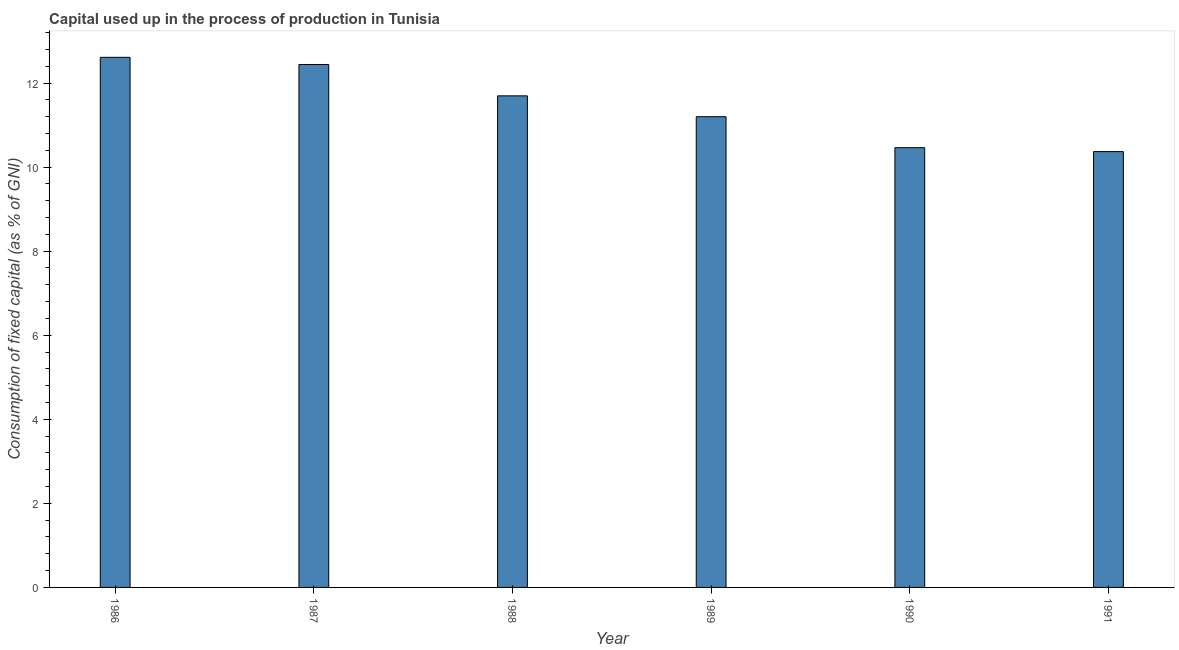Does the graph contain any zero values?
Your response must be concise. No. What is the title of the graph?
Ensure brevity in your answer.  Capital used up in the process of production in Tunisia. What is the label or title of the Y-axis?
Give a very brief answer. Consumption of fixed capital (as % of GNI). What is the consumption of fixed capital in 1991?
Ensure brevity in your answer.  10.37. Across all years, what is the maximum consumption of fixed capital?
Provide a short and direct response. 12.61. Across all years, what is the minimum consumption of fixed capital?
Your answer should be very brief. 10.37. In which year was the consumption of fixed capital minimum?
Make the answer very short. 1991. What is the sum of the consumption of fixed capital?
Offer a very short reply. 68.78. What is the difference between the consumption of fixed capital in 1986 and 1989?
Make the answer very short. 1.41. What is the average consumption of fixed capital per year?
Keep it short and to the point. 11.46. What is the median consumption of fixed capital?
Give a very brief answer. 11.45. What is the ratio of the consumption of fixed capital in 1989 to that in 1990?
Your answer should be compact. 1.07. Is the difference between the consumption of fixed capital in 1986 and 1987 greater than the difference between any two years?
Your answer should be very brief. No. What is the difference between the highest and the second highest consumption of fixed capital?
Your answer should be compact. 0.17. What is the difference between the highest and the lowest consumption of fixed capital?
Offer a terse response. 2.24. How many years are there in the graph?
Provide a succinct answer. 6. Are the values on the major ticks of Y-axis written in scientific E-notation?
Provide a short and direct response. No. What is the Consumption of fixed capital (as % of GNI) in 1986?
Give a very brief answer. 12.61. What is the Consumption of fixed capital (as % of GNI) of 1987?
Provide a short and direct response. 12.44. What is the Consumption of fixed capital (as % of GNI) of 1988?
Ensure brevity in your answer.  11.7. What is the Consumption of fixed capital (as % of GNI) in 1989?
Ensure brevity in your answer.  11.2. What is the Consumption of fixed capital (as % of GNI) of 1990?
Give a very brief answer. 10.46. What is the Consumption of fixed capital (as % of GNI) in 1991?
Your answer should be very brief. 10.37. What is the difference between the Consumption of fixed capital (as % of GNI) in 1986 and 1987?
Make the answer very short. 0.17. What is the difference between the Consumption of fixed capital (as % of GNI) in 1986 and 1988?
Provide a short and direct response. 0.92. What is the difference between the Consumption of fixed capital (as % of GNI) in 1986 and 1989?
Offer a very short reply. 1.41. What is the difference between the Consumption of fixed capital (as % of GNI) in 1986 and 1990?
Provide a short and direct response. 2.15. What is the difference between the Consumption of fixed capital (as % of GNI) in 1986 and 1991?
Ensure brevity in your answer.  2.24. What is the difference between the Consumption of fixed capital (as % of GNI) in 1987 and 1988?
Offer a very short reply. 0.75. What is the difference between the Consumption of fixed capital (as % of GNI) in 1987 and 1989?
Make the answer very short. 1.24. What is the difference between the Consumption of fixed capital (as % of GNI) in 1987 and 1990?
Your answer should be compact. 1.98. What is the difference between the Consumption of fixed capital (as % of GNI) in 1987 and 1991?
Ensure brevity in your answer.  2.07. What is the difference between the Consumption of fixed capital (as % of GNI) in 1988 and 1989?
Give a very brief answer. 0.5. What is the difference between the Consumption of fixed capital (as % of GNI) in 1988 and 1990?
Your response must be concise. 1.23. What is the difference between the Consumption of fixed capital (as % of GNI) in 1988 and 1991?
Your answer should be very brief. 1.33. What is the difference between the Consumption of fixed capital (as % of GNI) in 1989 and 1990?
Ensure brevity in your answer.  0.74. What is the difference between the Consumption of fixed capital (as % of GNI) in 1989 and 1991?
Provide a short and direct response. 0.83. What is the difference between the Consumption of fixed capital (as % of GNI) in 1990 and 1991?
Offer a terse response. 0.09. What is the ratio of the Consumption of fixed capital (as % of GNI) in 1986 to that in 1988?
Ensure brevity in your answer.  1.08. What is the ratio of the Consumption of fixed capital (as % of GNI) in 1986 to that in 1989?
Your answer should be compact. 1.13. What is the ratio of the Consumption of fixed capital (as % of GNI) in 1986 to that in 1990?
Provide a succinct answer. 1.21. What is the ratio of the Consumption of fixed capital (as % of GNI) in 1986 to that in 1991?
Make the answer very short. 1.22. What is the ratio of the Consumption of fixed capital (as % of GNI) in 1987 to that in 1988?
Make the answer very short. 1.06. What is the ratio of the Consumption of fixed capital (as % of GNI) in 1987 to that in 1989?
Keep it short and to the point. 1.11. What is the ratio of the Consumption of fixed capital (as % of GNI) in 1987 to that in 1990?
Ensure brevity in your answer.  1.19. What is the ratio of the Consumption of fixed capital (as % of GNI) in 1987 to that in 1991?
Your response must be concise. 1.2. What is the ratio of the Consumption of fixed capital (as % of GNI) in 1988 to that in 1989?
Offer a terse response. 1.04. What is the ratio of the Consumption of fixed capital (as % of GNI) in 1988 to that in 1990?
Your response must be concise. 1.12. What is the ratio of the Consumption of fixed capital (as % of GNI) in 1988 to that in 1991?
Your answer should be compact. 1.13. What is the ratio of the Consumption of fixed capital (as % of GNI) in 1989 to that in 1990?
Offer a very short reply. 1.07. What is the ratio of the Consumption of fixed capital (as % of GNI) in 1989 to that in 1991?
Keep it short and to the point. 1.08. 